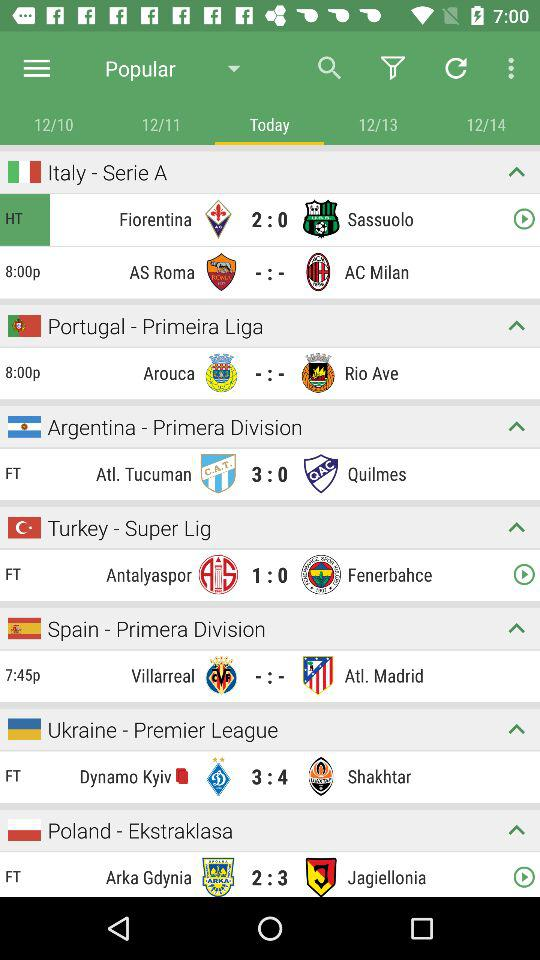What is the score of the match between "Fiorentina" and "Sassuolo"? The score of the match is "Fiorentina": 2 and "Sassuolo": 0. 